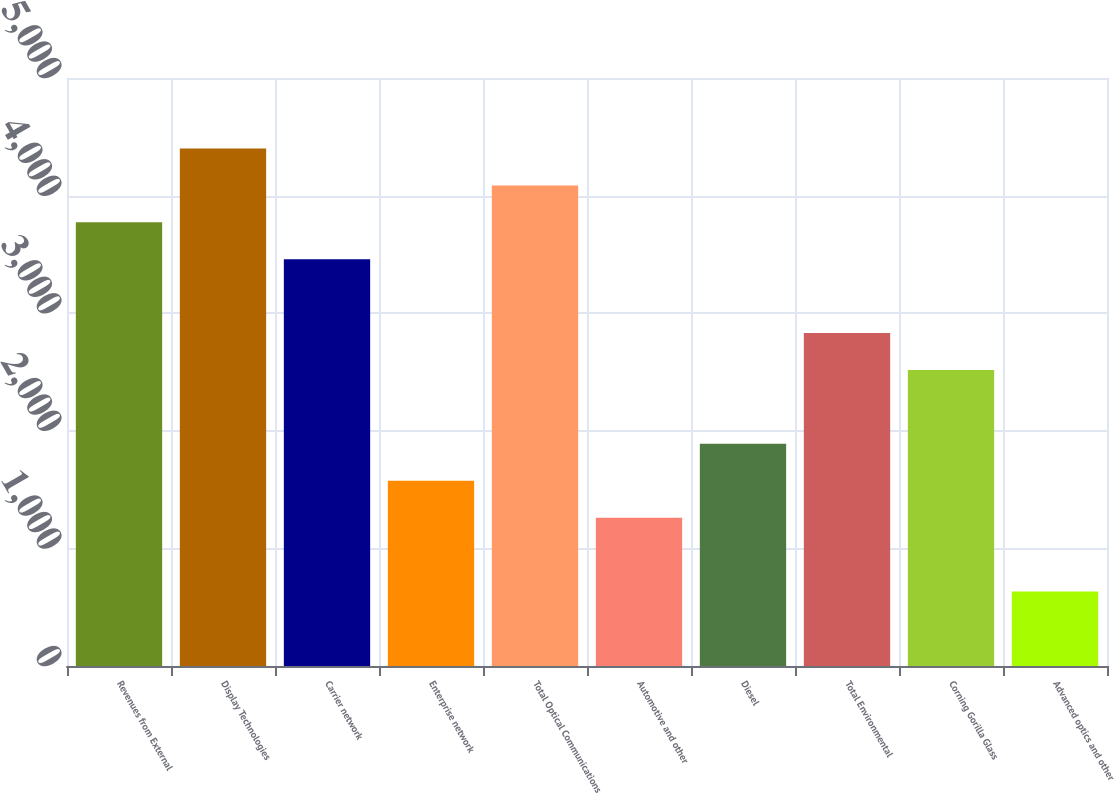Convert chart. <chart><loc_0><loc_0><loc_500><loc_500><bar_chart><fcel>Revenues from External<fcel>Display Technologies<fcel>Carrier network<fcel>Enterprise network<fcel>Total Optical Communications<fcel>Automotive and other<fcel>Diesel<fcel>Total Environmental<fcel>Corning Gorilla Glass<fcel>Advanced optics and other<nl><fcel>3772.8<fcel>4400.6<fcel>3458.9<fcel>1575.5<fcel>4086.7<fcel>1261.6<fcel>1889.4<fcel>2831.1<fcel>2517.2<fcel>633.8<nl></chart> 